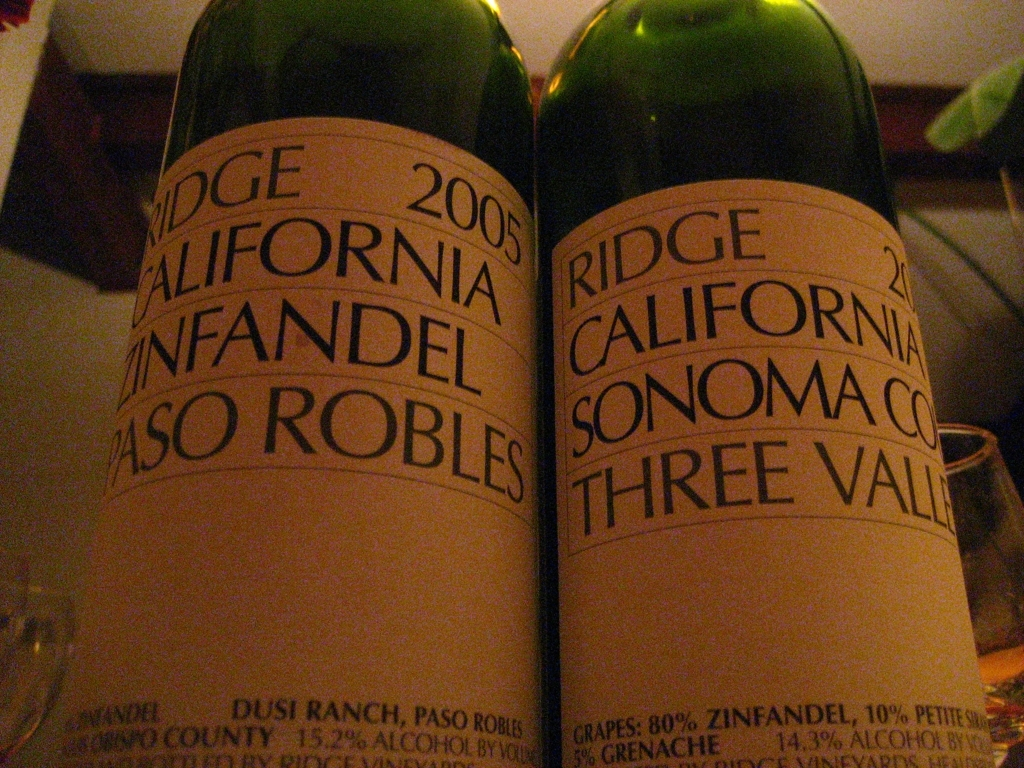Is the background heavily blurred?
A. No
B. Yes
Answer with the option's letter from the given choices directly.
 B. 